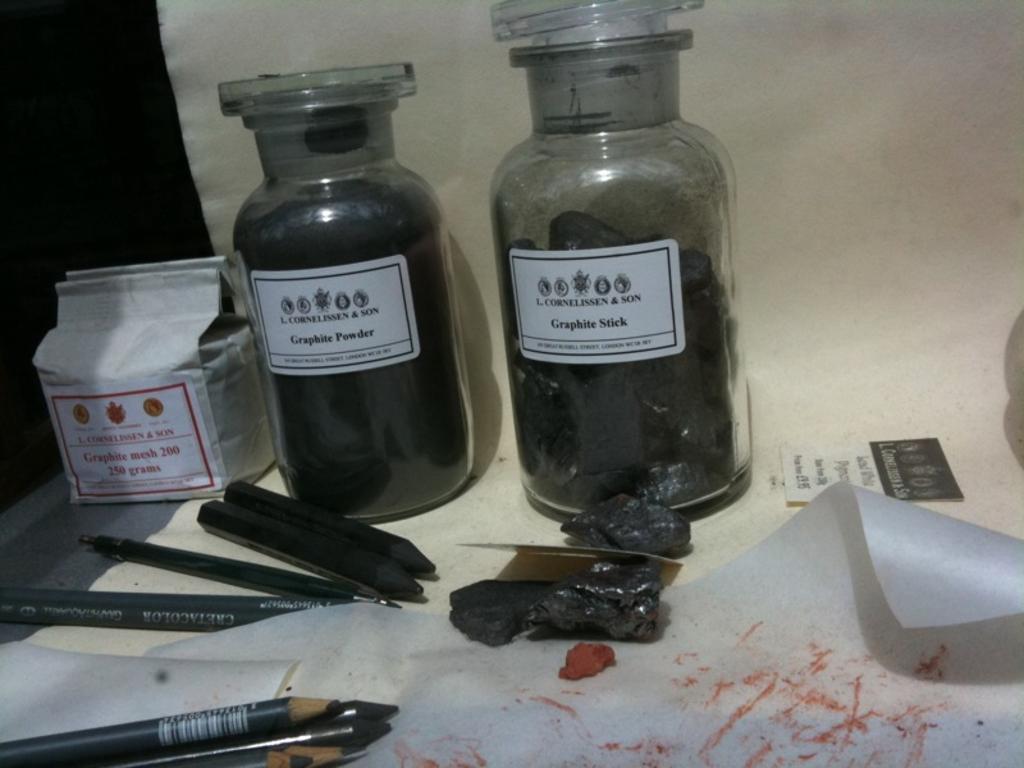Can you describe this image briefly? In this image we can see two glass bottles, a papers stick to the bottles and in the bottom we can see some pencils, on the left side can see a paper. 